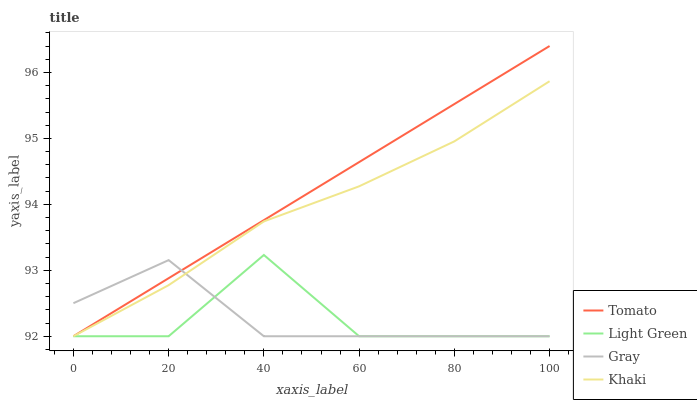Does Light Green have the minimum area under the curve?
Answer yes or no. Yes. Does Tomato have the maximum area under the curve?
Answer yes or no. Yes. Does Gray have the minimum area under the curve?
Answer yes or no. No. Does Gray have the maximum area under the curve?
Answer yes or no. No. Is Tomato the smoothest?
Answer yes or no. Yes. Is Light Green the roughest?
Answer yes or no. Yes. Is Gray the smoothest?
Answer yes or no. No. Is Gray the roughest?
Answer yes or no. No. Does Tomato have the lowest value?
Answer yes or no. Yes. Does Tomato have the highest value?
Answer yes or no. Yes. Does Khaki have the highest value?
Answer yes or no. No. Does Gray intersect Tomato?
Answer yes or no. Yes. Is Gray less than Tomato?
Answer yes or no. No. Is Gray greater than Tomato?
Answer yes or no. No. 